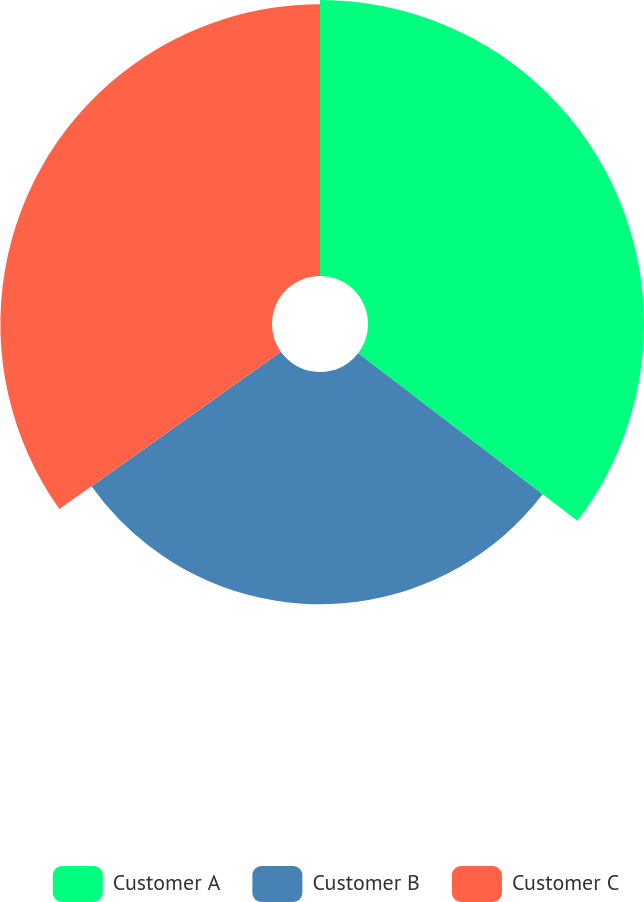Convert chart. <chart><loc_0><loc_0><loc_500><loc_500><pie_chart><fcel>Customer A<fcel>Customer B<fcel>Customer C<nl><fcel>35.39%<fcel>29.78%<fcel>34.83%<nl></chart> 